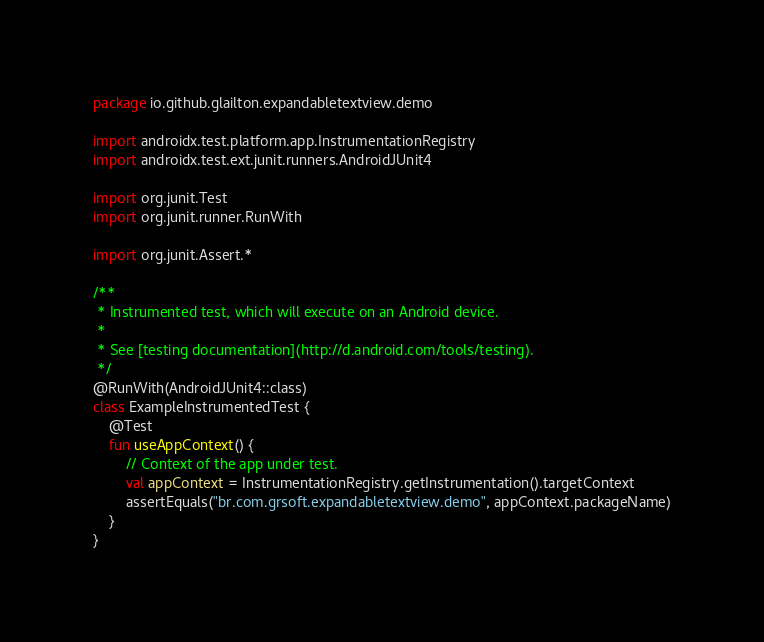Convert code to text. <code><loc_0><loc_0><loc_500><loc_500><_Kotlin_>package io.github.glailton.expandabletextview.demo

import androidx.test.platform.app.InstrumentationRegistry
import androidx.test.ext.junit.runners.AndroidJUnit4

import org.junit.Test
import org.junit.runner.RunWith

import org.junit.Assert.*

/**
 * Instrumented test, which will execute on an Android device.
 *
 * See [testing documentation](http://d.android.com/tools/testing).
 */
@RunWith(AndroidJUnit4::class)
class ExampleInstrumentedTest {
    @Test
    fun useAppContext() {
        // Context of the app under test.
        val appContext = InstrumentationRegistry.getInstrumentation().targetContext
        assertEquals("br.com.grsoft.expandabletextview.demo", appContext.packageName)
    }
}</code> 